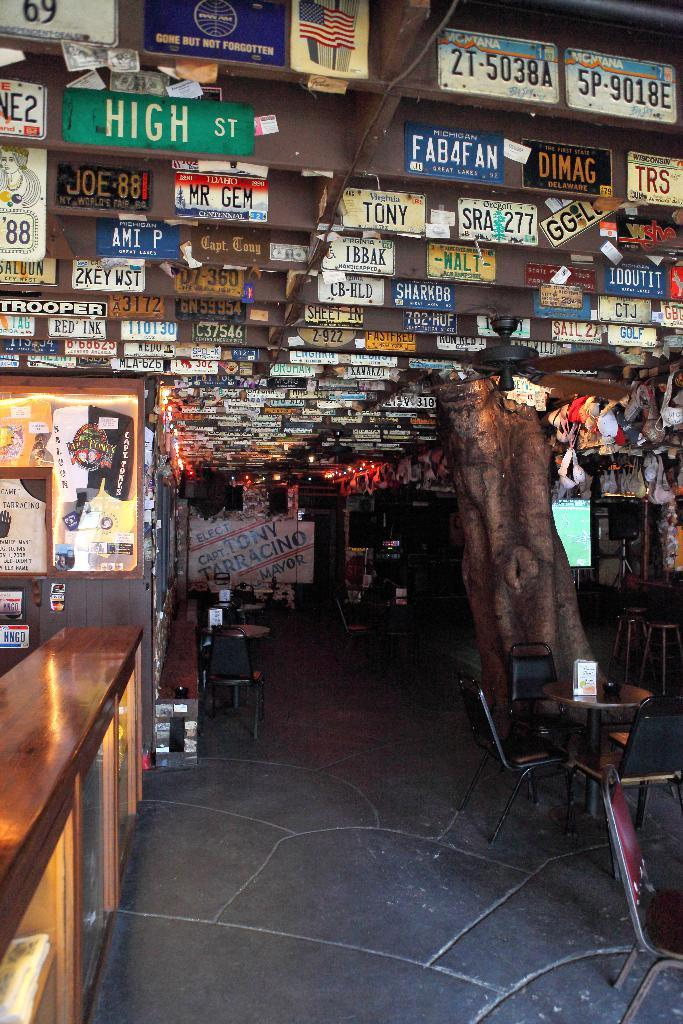<image>
Offer a succinct explanation of the picture presented. A restaurant with a lot of signs on the ceiling one says high st. 